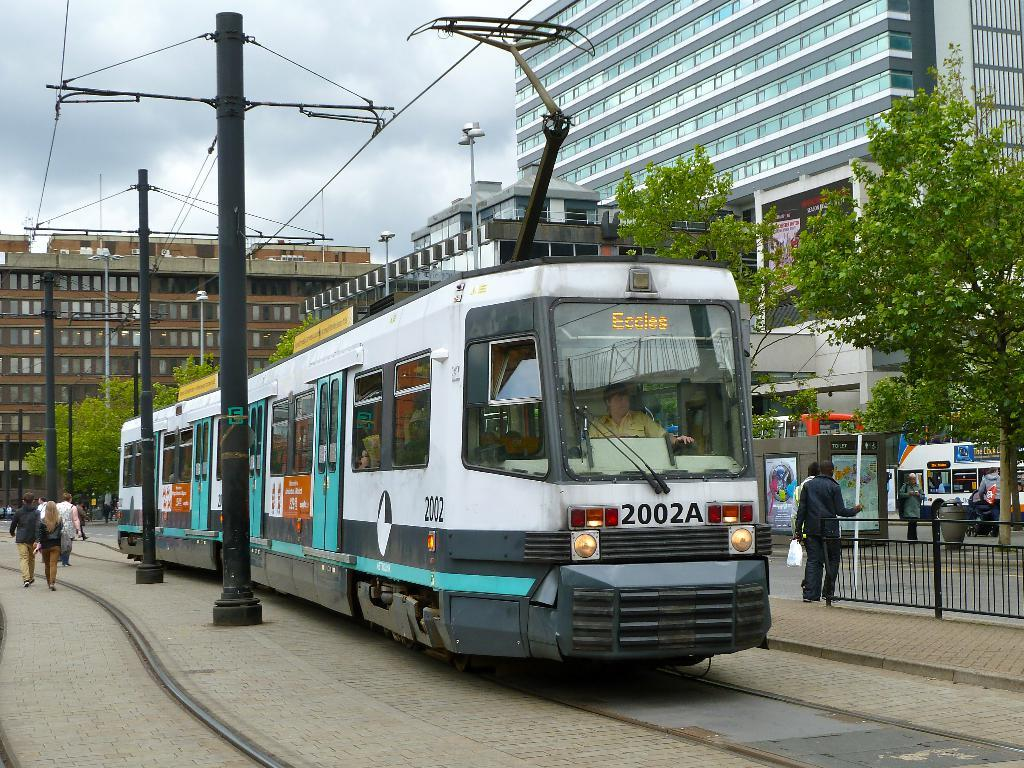<image>
Share a concise interpretation of the image provided. A subway train number 2002A travels through a city while attached to power lines. 